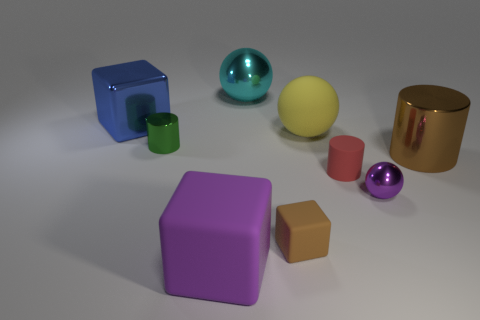Are there more large matte objects right of the large cyan metallic object than big cyan spheres that are in front of the yellow sphere?
Keep it short and to the point. Yes. Are there any brown things that are in front of the big cube in front of the blue metal thing?
Offer a terse response. No. How many purple things are there?
Your answer should be very brief. 2. Is the color of the tiny shiny cylinder the same as the big block in front of the big blue metal cube?
Offer a very short reply. No. Is the number of big metal cylinders greater than the number of big red metal blocks?
Your response must be concise. Yes. Is there any other thing that is the same color as the small ball?
Your answer should be compact. Yes. How many other things are the same size as the purple metallic object?
Offer a terse response. 3. What is the material of the big cube that is right of the large metallic thing that is on the left side of the large ball behind the big yellow matte thing?
Provide a short and direct response. Rubber. Is the material of the blue cube the same as the purple thing that is on the right side of the tiny brown rubber block?
Provide a short and direct response. Yes. Is the number of purple spheres behind the red object less than the number of big objects in front of the small brown block?
Provide a succinct answer. Yes. 